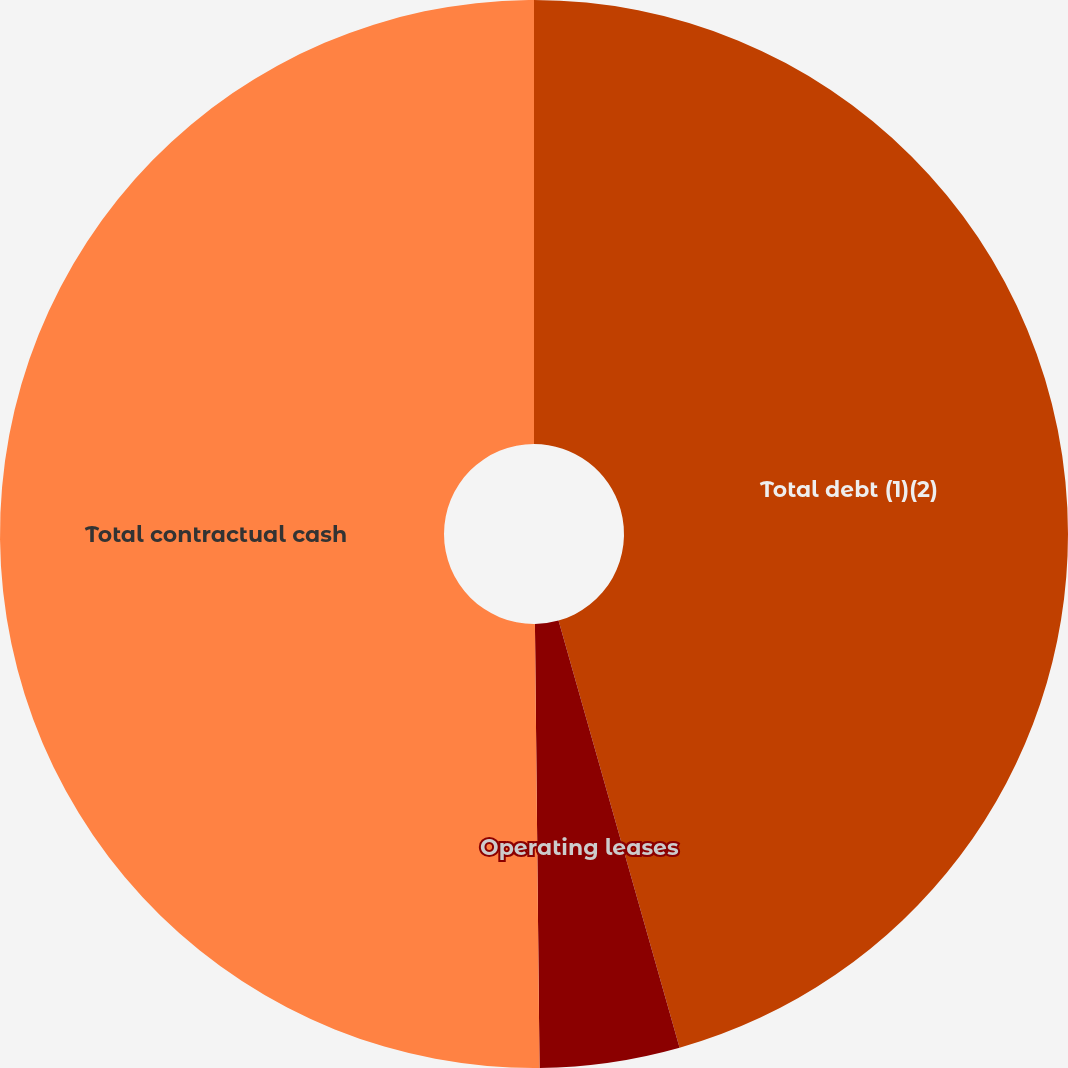Convert chart. <chart><loc_0><loc_0><loc_500><loc_500><pie_chart><fcel>Total debt (1)(2)<fcel>Operating leases<fcel>Total contractual cash<nl><fcel>45.61%<fcel>4.23%<fcel>50.17%<nl></chart> 